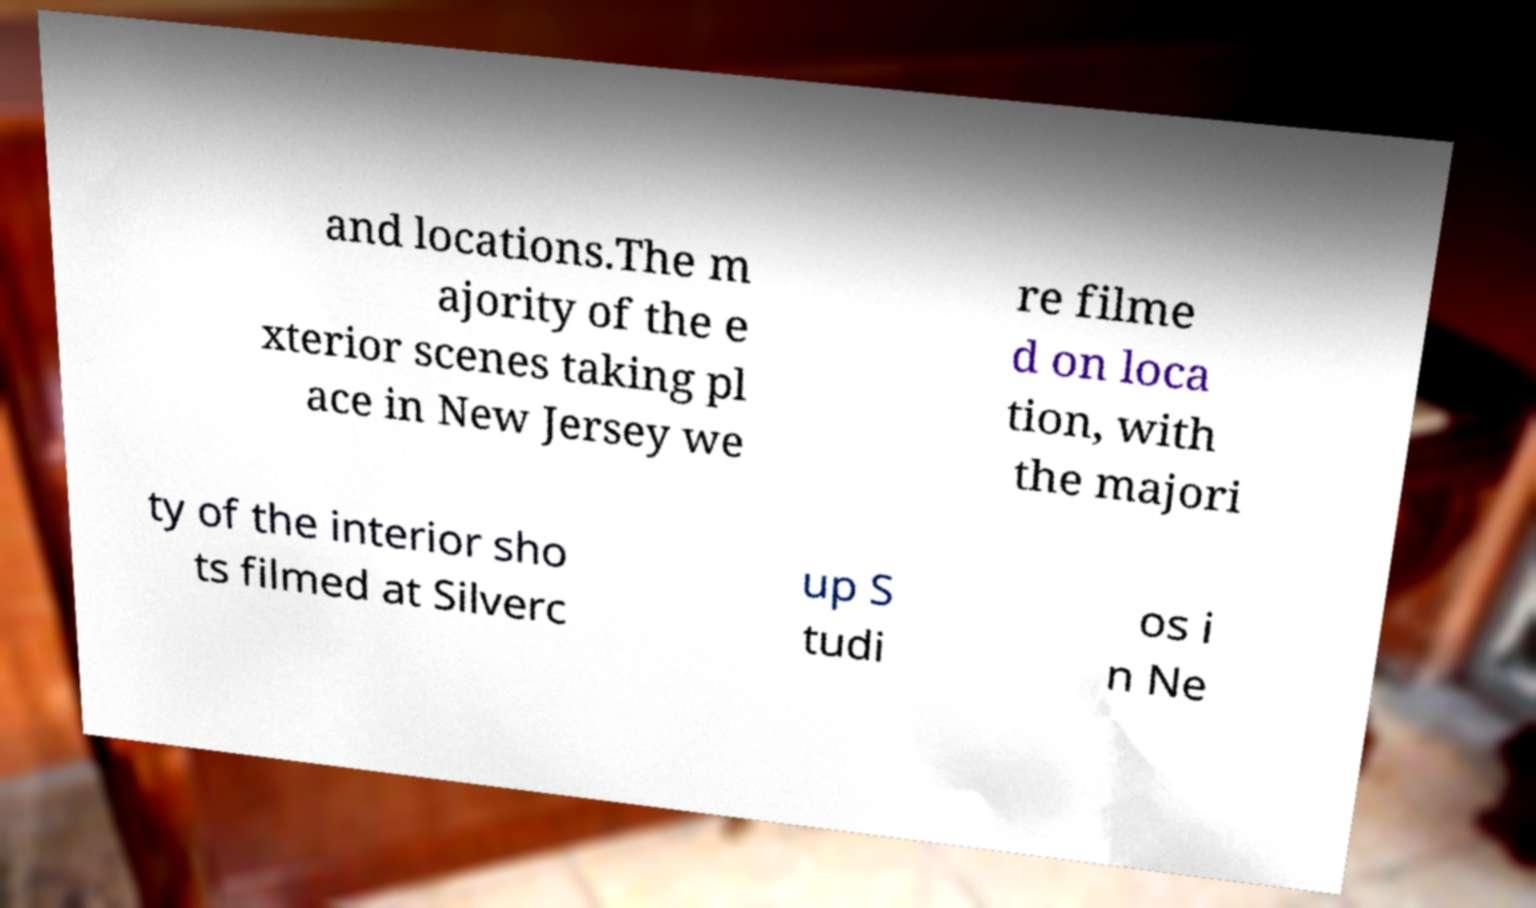Can you read and provide the text displayed in the image?This photo seems to have some interesting text. Can you extract and type it out for me? and locations.The m ajority of the e xterior scenes taking pl ace in New Jersey we re filme d on loca tion, with the majori ty of the interior sho ts filmed at Silverc up S tudi os i n Ne 